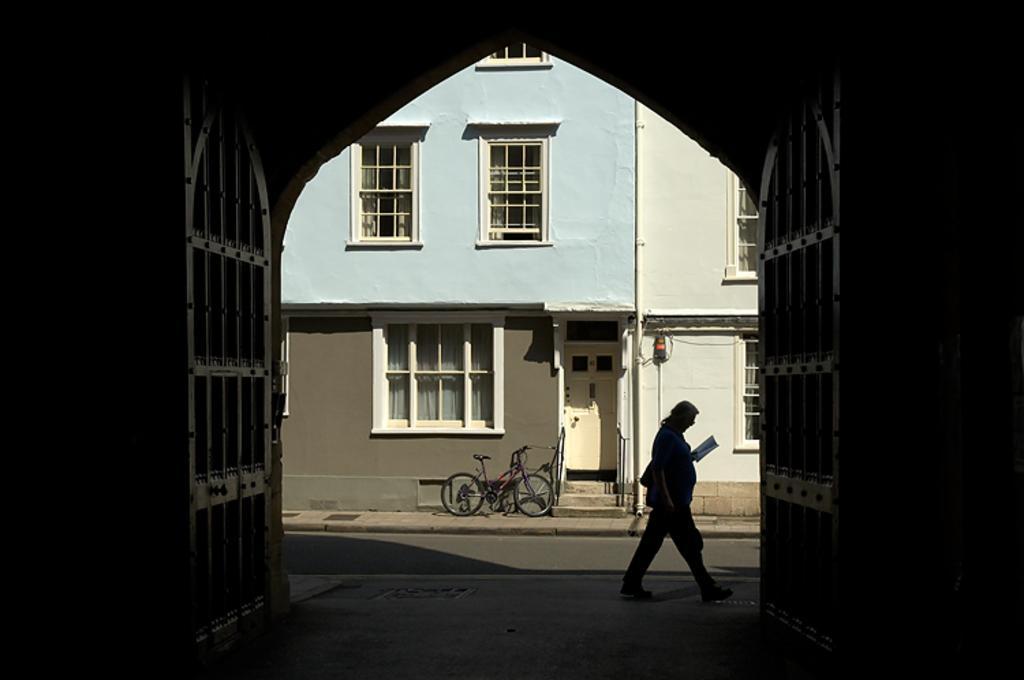Describe this image in one or two sentences. In this image there is a gate opens and a person is walking by holding a book and reading. And there is a bicycle and also in background I can see a building 